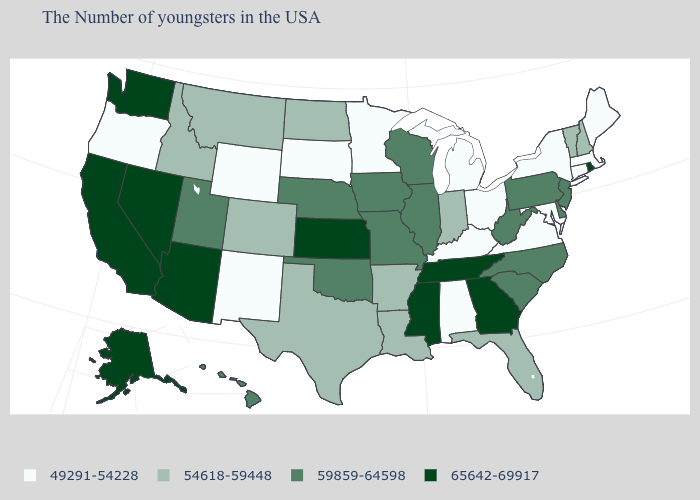Does Colorado have a lower value than Delaware?
Answer briefly. Yes. Name the states that have a value in the range 65642-69917?
Give a very brief answer. Rhode Island, Georgia, Tennessee, Mississippi, Kansas, Arizona, Nevada, California, Washington, Alaska. Name the states that have a value in the range 54618-59448?
Keep it brief. New Hampshire, Vermont, Florida, Indiana, Louisiana, Arkansas, Texas, North Dakota, Colorado, Montana, Idaho. Among the states that border New York , which have the lowest value?
Answer briefly. Massachusetts, Connecticut. Which states hav the highest value in the MidWest?
Write a very short answer. Kansas. What is the highest value in the USA?
Be succinct. 65642-69917. Name the states that have a value in the range 65642-69917?
Keep it brief. Rhode Island, Georgia, Tennessee, Mississippi, Kansas, Arizona, Nevada, California, Washington, Alaska. Name the states that have a value in the range 49291-54228?
Keep it brief. Maine, Massachusetts, Connecticut, New York, Maryland, Virginia, Ohio, Michigan, Kentucky, Alabama, Minnesota, South Dakota, Wyoming, New Mexico, Oregon. What is the value of Hawaii?
Keep it brief. 59859-64598. What is the value of New York?
Give a very brief answer. 49291-54228. Among the states that border South Carolina , does Georgia have the highest value?
Answer briefly. Yes. Among the states that border Tennessee , does Alabama have the lowest value?
Short answer required. Yes. Does Maryland have the lowest value in the USA?
Concise answer only. Yes. What is the value of Arizona?
Concise answer only. 65642-69917. What is the highest value in states that border Mississippi?
Give a very brief answer. 65642-69917. 